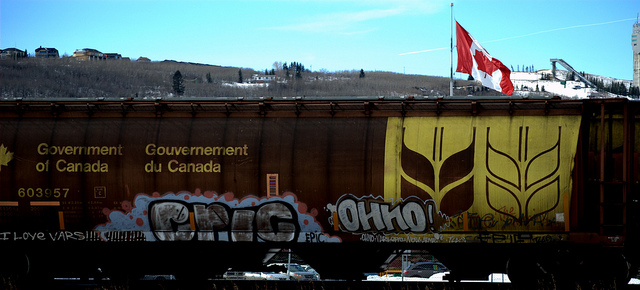Please transcribe the text information in this image. Gouvernment du Canada Government 01 Canada 603957 LOVE VARS OHHO EPIC 